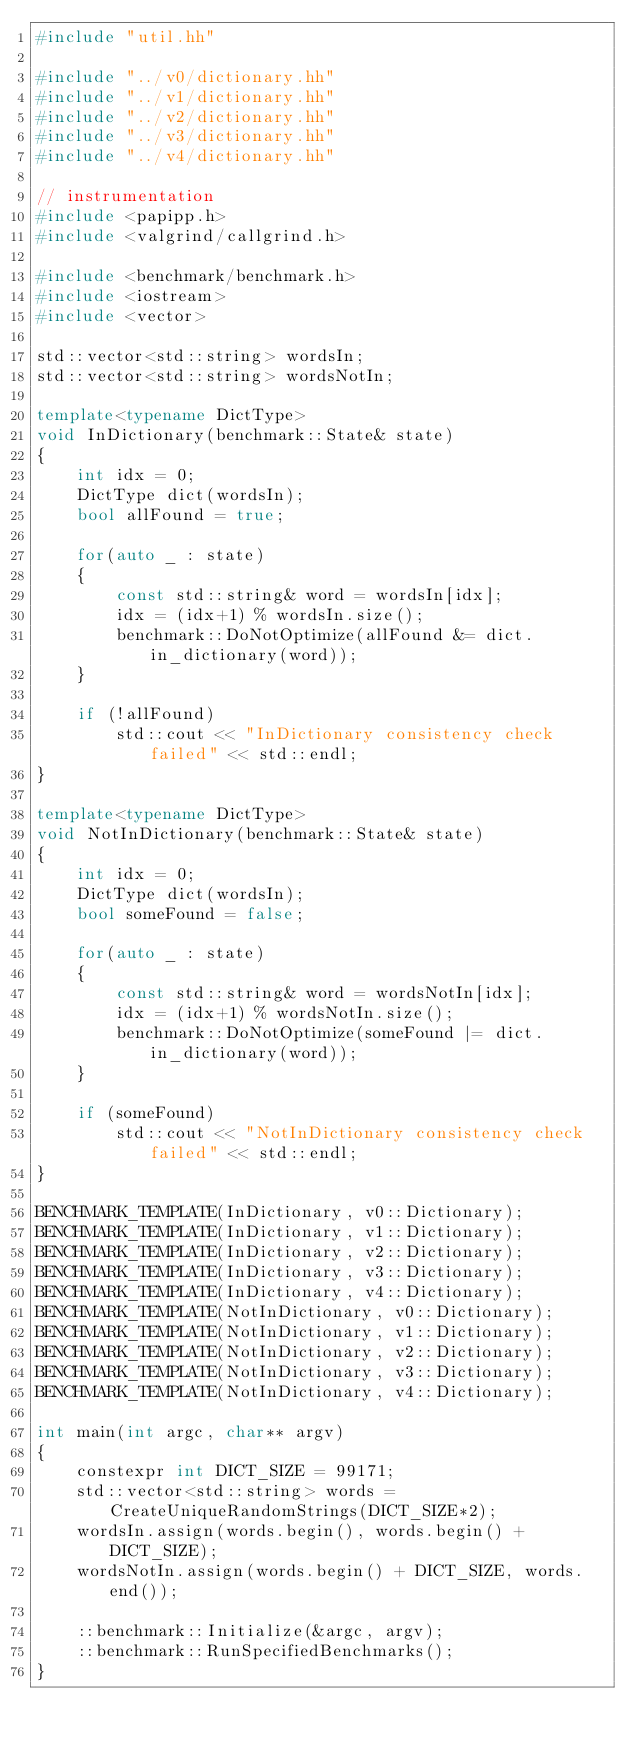<code> <loc_0><loc_0><loc_500><loc_500><_C++_>#include "util.hh"

#include "../v0/dictionary.hh"
#include "../v1/dictionary.hh"
#include "../v2/dictionary.hh"
#include "../v3/dictionary.hh"
#include "../v4/dictionary.hh"

// instrumentation
#include <papipp.h>
#include <valgrind/callgrind.h>

#include <benchmark/benchmark.h>
#include <iostream>
#include <vector>

std::vector<std::string> wordsIn;
std::vector<std::string> wordsNotIn;

template<typename DictType>
void InDictionary(benchmark::State& state)
{
    int idx = 0;
    DictType dict(wordsIn);
    bool allFound = true;

    for(auto _ : state)
    {
        const std::string& word = wordsIn[idx];
        idx = (idx+1) % wordsIn.size();
        benchmark::DoNotOptimize(allFound &= dict.in_dictionary(word));
    }

    if (!allFound)
        std::cout << "InDictionary consistency check failed" << std::endl;
}

template<typename DictType>
void NotInDictionary(benchmark::State& state)
{
    int idx = 0;
    DictType dict(wordsIn);
    bool someFound = false;

    for(auto _ : state)
    {
        const std::string& word = wordsNotIn[idx];
        idx = (idx+1) % wordsNotIn.size();
        benchmark::DoNotOptimize(someFound |= dict.in_dictionary(word));
    }

    if (someFound)
        std::cout << "NotInDictionary consistency check failed" << std::endl;
}

BENCHMARK_TEMPLATE(InDictionary, v0::Dictionary);
BENCHMARK_TEMPLATE(InDictionary, v1::Dictionary);
BENCHMARK_TEMPLATE(InDictionary, v2::Dictionary);
BENCHMARK_TEMPLATE(InDictionary, v3::Dictionary);
BENCHMARK_TEMPLATE(InDictionary, v4::Dictionary);
BENCHMARK_TEMPLATE(NotInDictionary, v0::Dictionary);
BENCHMARK_TEMPLATE(NotInDictionary, v1::Dictionary);
BENCHMARK_TEMPLATE(NotInDictionary, v2::Dictionary);
BENCHMARK_TEMPLATE(NotInDictionary, v3::Dictionary);
BENCHMARK_TEMPLATE(NotInDictionary, v4::Dictionary);

int main(int argc, char** argv)
{
    constexpr int DICT_SIZE = 99171;
    std::vector<std::string> words = CreateUniqueRandomStrings(DICT_SIZE*2);
    wordsIn.assign(words.begin(), words.begin() + DICT_SIZE);
    wordsNotIn.assign(words.begin() + DICT_SIZE, words.end());

    ::benchmark::Initialize(&argc, argv);
    ::benchmark::RunSpecifiedBenchmarks();
}
</code> 